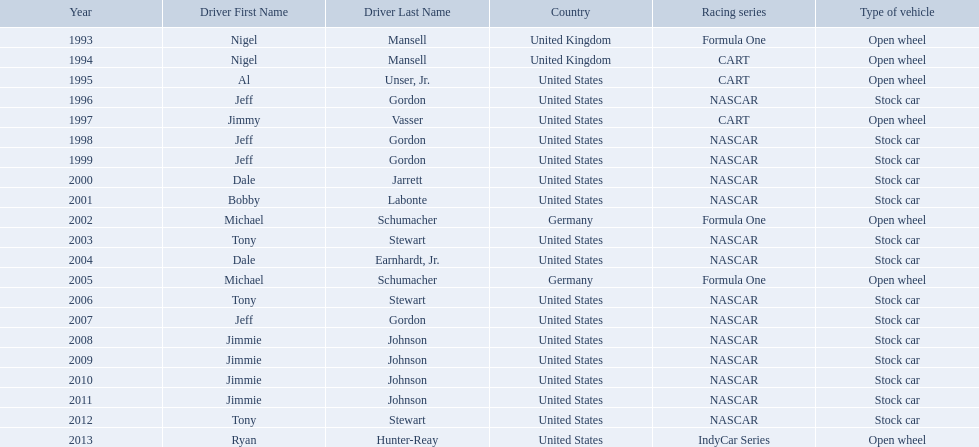Who won an espy in the year 2004, bobby labonte, tony stewart, dale earnhardt jr., or jeff gordon? Dale Earnhardt, Jr. Who won the espy in the year 1997; nigel mansell, al unser, jr., jeff gordon, or jimmy vasser? Jimmy Vasser. Which one only has one espy; nigel mansell, al unser jr., michael schumacher, or jeff gordon? Al Unser, Jr. What year(s) did nigel mansel receive epsy awards? 1993, 1994. What year(s) did michael schumacher receive epsy awards? 2002, 2005. What year(s) did jeff gordon receive epsy awards? 1996, 1998, 1999, 2007. What year(s) did al unser jr. receive epsy awards? 1995. Which driver only received one epsy award? Al Unser, Jr. 